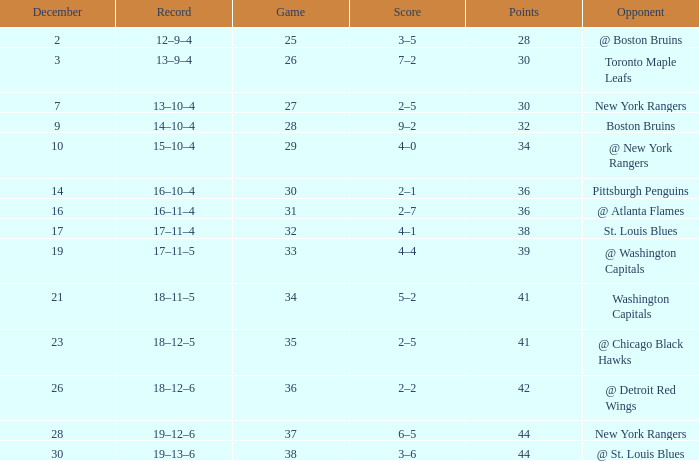Which Score has Points of 36, and a Game of 30? 2–1. 